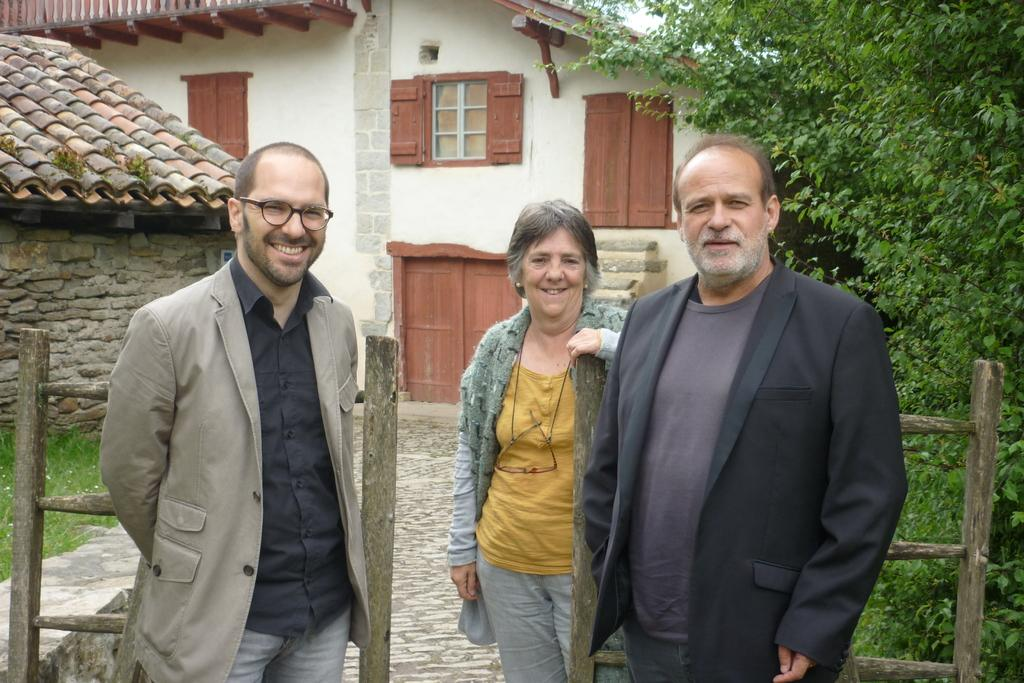How many people are in the foreground of the image? There are two men and a woman in the foreground of the image. What are the people near in the image? They are standing near a wooden railing. What structures can be seen in the background of the image? There is a house and a hut in the background of the image. What type of vegetation is present in the background of the image? Grass and trees are present in the background of the image. What type of button can be seen on the stick in the image? There is no button or stick present in the image. 